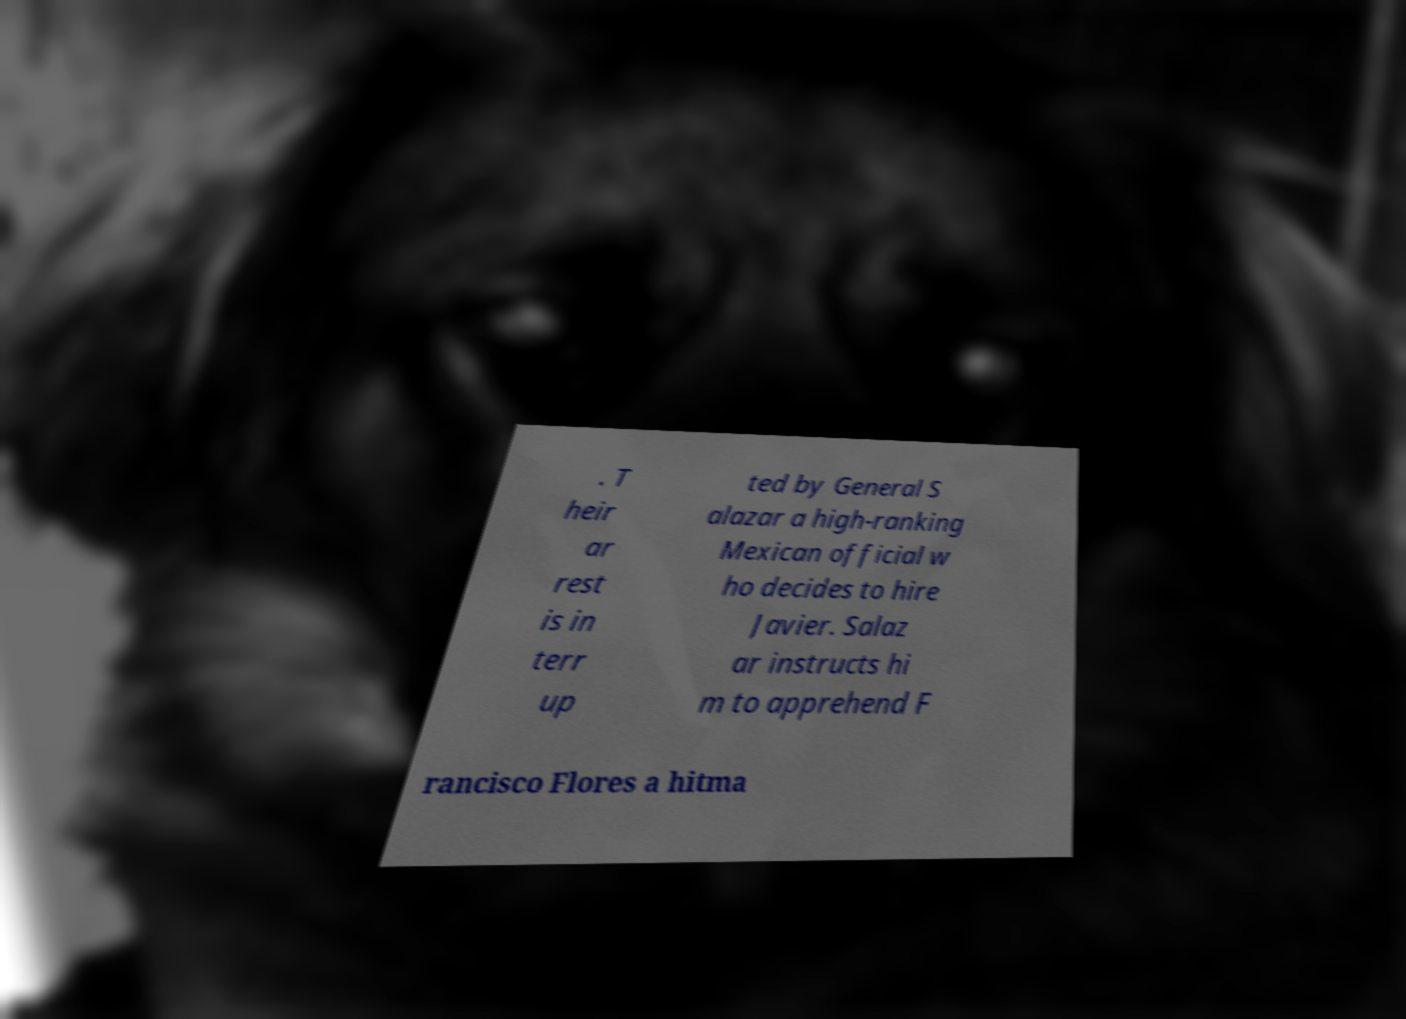There's text embedded in this image that I need extracted. Can you transcribe it verbatim? . T heir ar rest is in terr up ted by General S alazar a high-ranking Mexican official w ho decides to hire Javier. Salaz ar instructs hi m to apprehend F rancisco Flores a hitma 